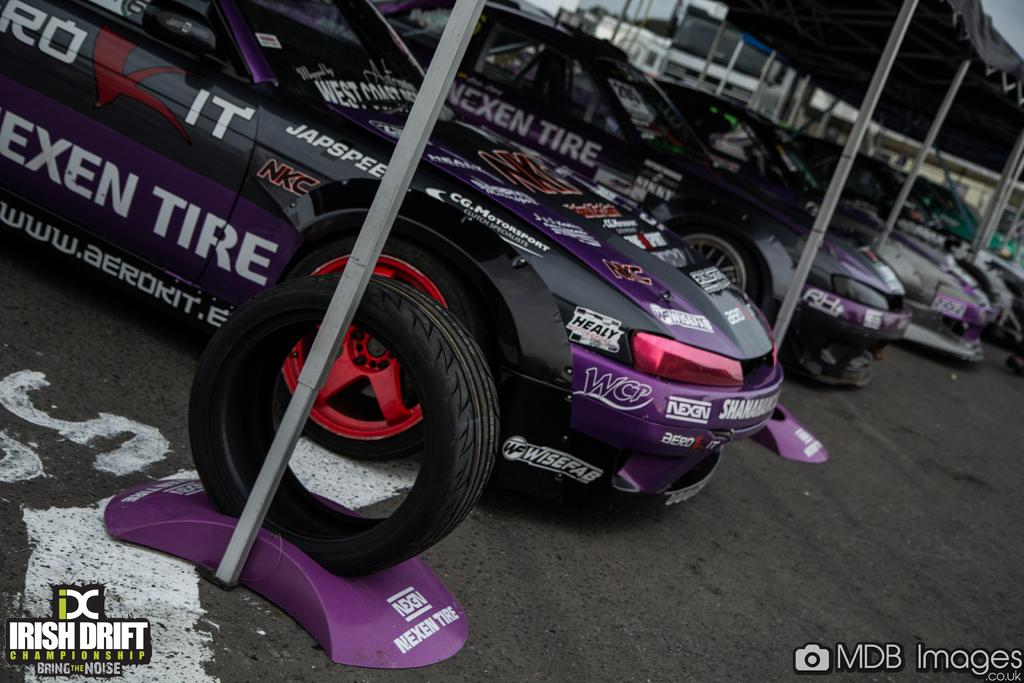What type of vehicles are in the image? There are sports cars in the image. How are the sports cars arranged in the image? The sports cars are placed in a row. What can be seen in the background of the image? There is a tent in the background of the image. What is visible at the bottom of the image? There is a road visible at the bottom of the image. What type of jeans is the wren wearing in the image? There is no wren or jeans present in the image. 